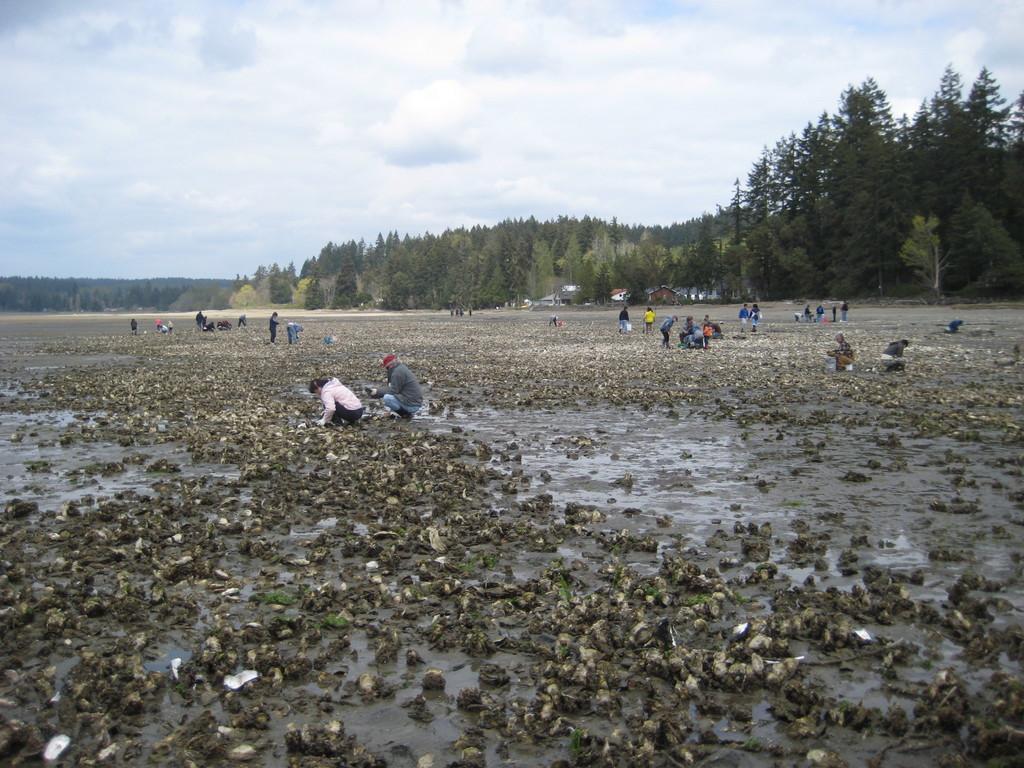How would you summarize this image in a sentence or two? In this picture there are people and we can see ground and objects. In the background of the image we can see trees, houses and sky. 